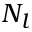<formula> <loc_0><loc_0><loc_500><loc_500>N _ { l }</formula> 